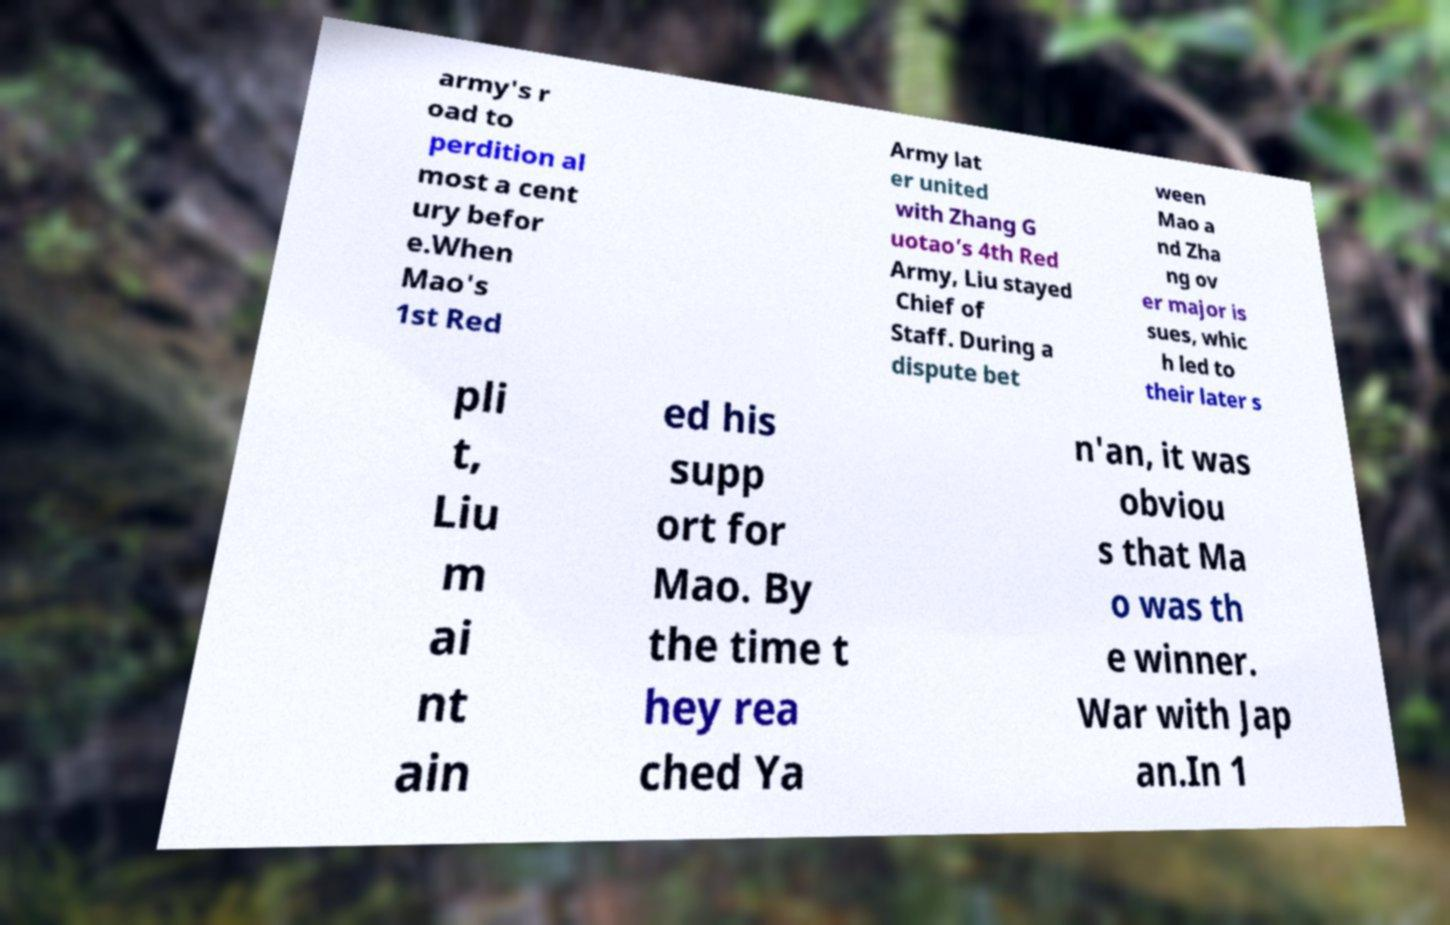Can you read and provide the text displayed in the image?This photo seems to have some interesting text. Can you extract and type it out for me? army's r oad to perdition al most a cent ury befor e.When Mao's 1st Red Army lat er united with Zhang G uotao’s 4th Red Army, Liu stayed Chief of Staff. During a dispute bet ween Mao a nd Zha ng ov er major is sues, whic h led to their later s pli t, Liu m ai nt ain ed his supp ort for Mao. By the time t hey rea ched Ya n'an, it was obviou s that Ma o was th e winner. War with Jap an.In 1 